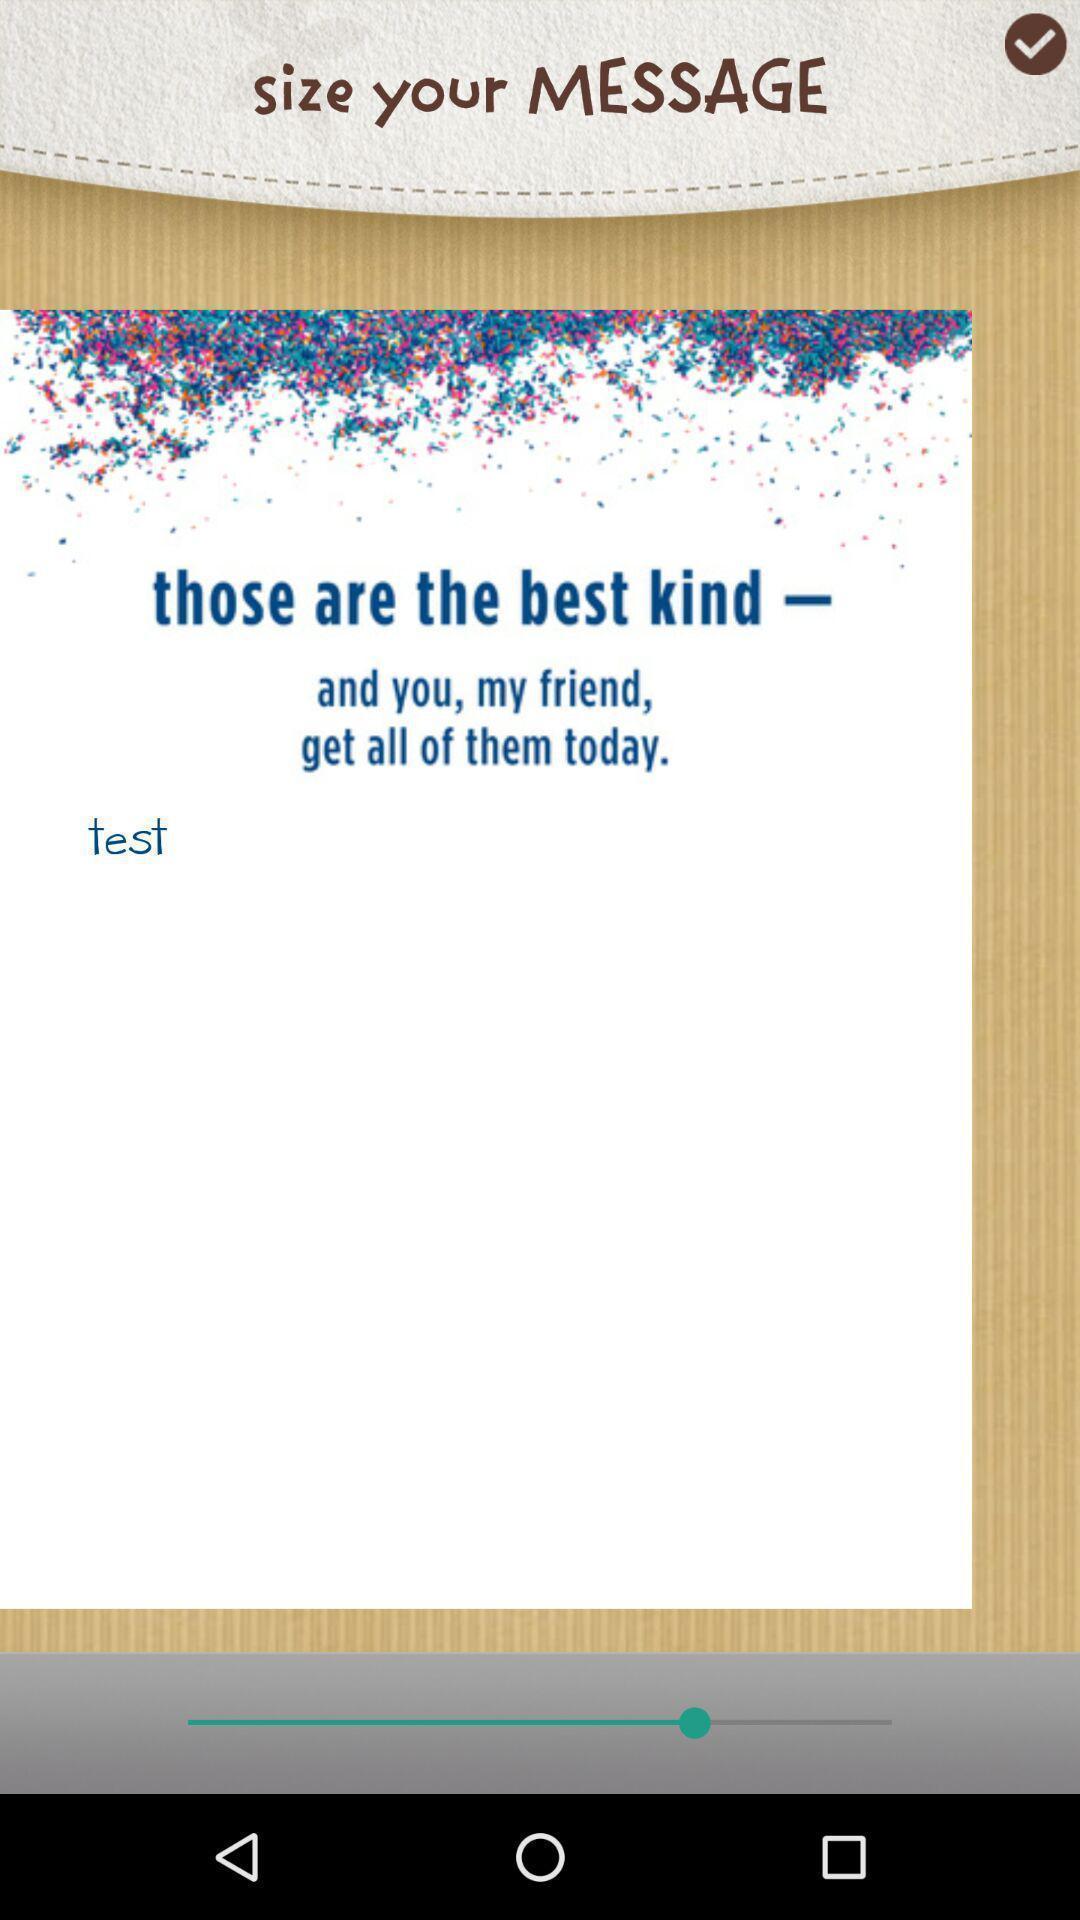Please provide a description for this image. Pop-up shows text message. 